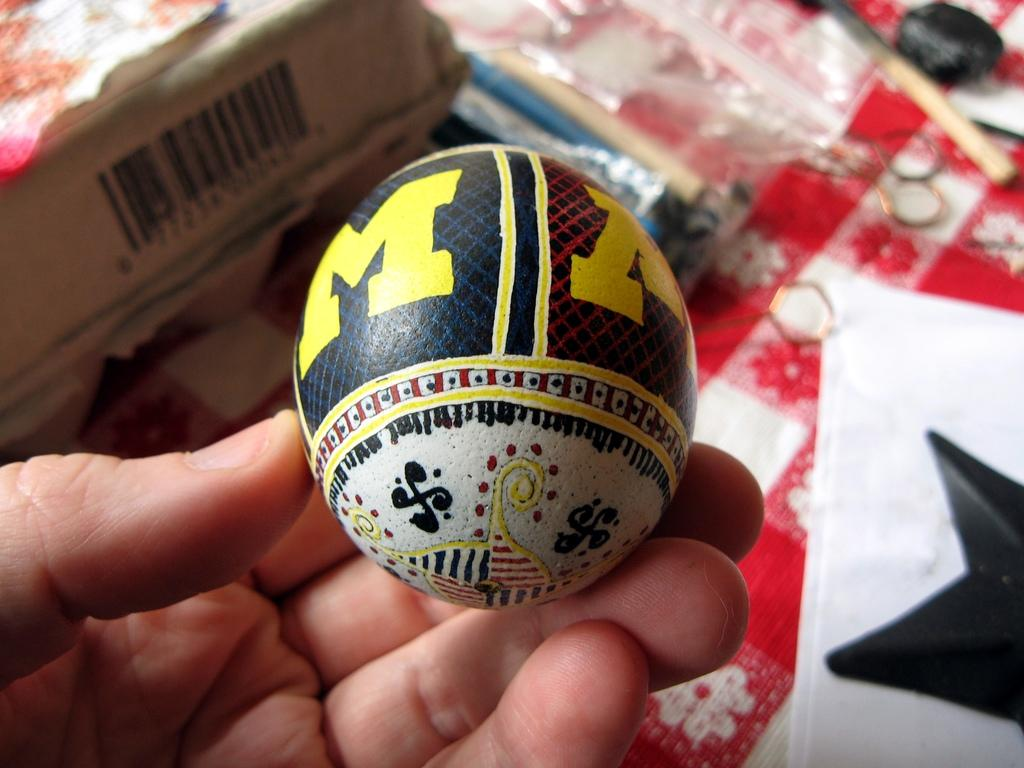What is the person's hand doing in the image? The person's hand is holding a ball in the image. Can you describe any other objects present in the image? Unfortunately, the provided facts do not mention any other objects present in the image. What type of cable can be seen connecting the airport to the low-hanging clouds in the image? There is no airport, low-hanging clouds, or cable present in the image. 